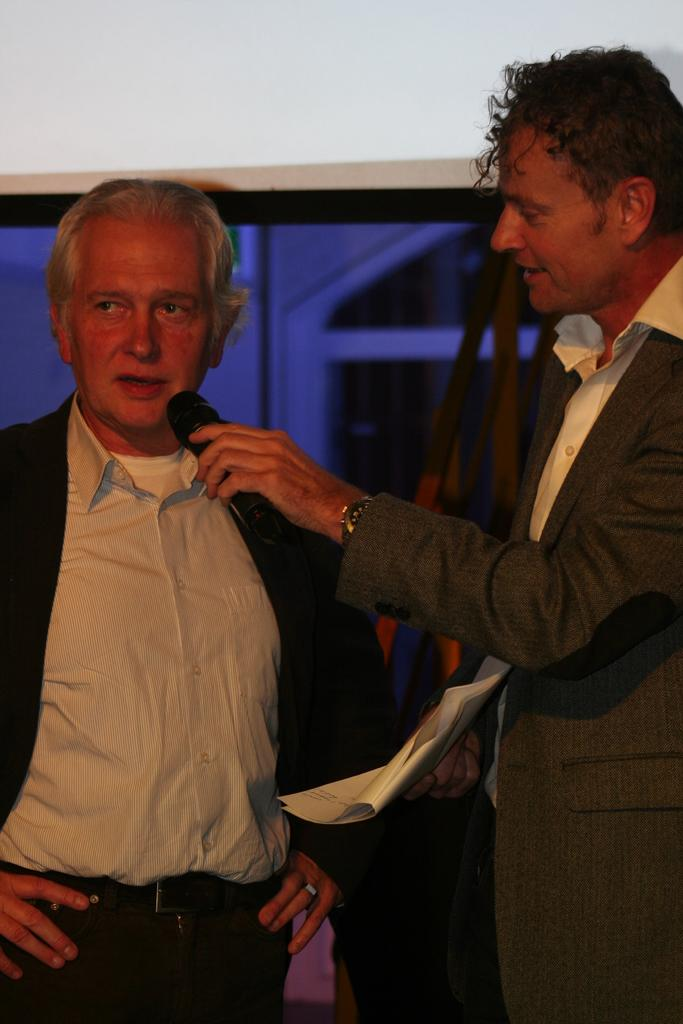How many people are visible in the image? There are two men standing in the front of the image. What is the man on the right side holding? The man on the right side is holding papers and a microphone. What is the man on the left side doing? The man on the left side is speaking. What type of animal can be seen in the image? There are no animals present in the image. What is the engine used for in the image? There is no engine present in the image. 